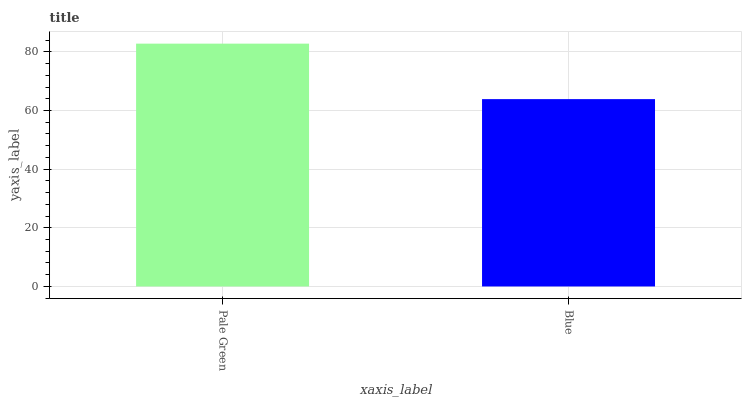Is Blue the minimum?
Answer yes or no. Yes. Is Pale Green the maximum?
Answer yes or no. Yes. Is Blue the maximum?
Answer yes or no. No. Is Pale Green greater than Blue?
Answer yes or no. Yes. Is Blue less than Pale Green?
Answer yes or no. Yes. Is Blue greater than Pale Green?
Answer yes or no. No. Is Pale Green less than Blue?
Answer yes or no. No. Is Pale Green the high median?
Answer yes or no. Yes. Is Blue the low median?
Answer yes or no. Yes. Is Blue the high median?
Answer yes or no. No. Is Pale Green the low median?
Answer yes or no. No. 